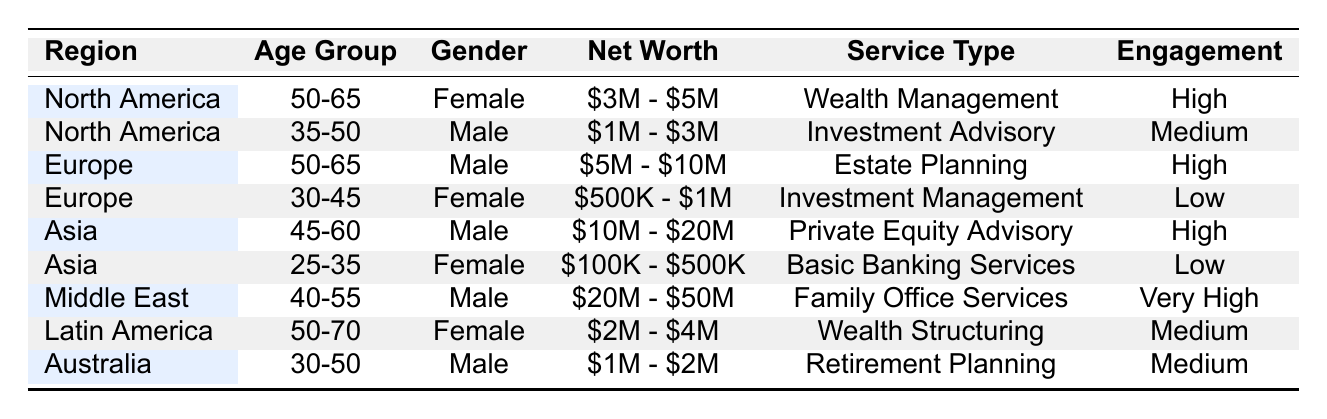What popular service type is associated with clients aged 50-65 in North America? In the North America section of the table, the entry with an age group of 50-65 shows the service type "Wealth Management."
Answer: Wealth Management Which region has the highest engagement level for male clients? The Middle East has a male client in the age group 40-55 with an engagement level of "Very High."
Answer: Middle East What is the net worth range of the female clients in Asia? The female clients in Asia are in the age group 25-35, with a net worth range of "$100K - $500K."
Answer: $100K - $500K Are there any clients aged 30-45 in Europe? Yes, there is a female client aged 30-45 in Europe with a net worth of "$500K - $1M."
Answer: Yes How does the engagement level of clients in Latin America compare to those in Europe? In Latin America, the engagement level for clients aged 50-70 is "Medium." In Europe, the engagement level for the 50-65 male client is "High," while the 30-45 female client's engagement is "Low." Thus, engagement levels vary with one being medium and the other high or low.
Answer: Varies: High and Medium What percentage of the clients in this table are from the Asia region? There are 8 total entries in the table, and 2 are from Asia. Therefore, the percentage of clients from Asia is (2/8)*100 = 25%.
Answer: 25% Which net worth category has the greatest representation among female clients? The table has two female clients with net worth categories: one with "$3M - $5M" in North America and another with "$2M - $4M" in Latin America. The representation includes a range of "2M - 5M" dollars.
Answer: $2M - $5M If we wanted to find the average net worth of males in the table, what would that require? To find the average net worth of males, we would need to convert the ranges to numerical values, sum them up, and then divide by the number of male clients listed. The listed male clients have ranges of "$5M - $10M," "$10M - $20M," and "$20M - $50M." Calculating that involves more detailed estimates of these ranges.
Answer: Requires calculations Is the engagement level for clients in the 25-35 age group across all regions generally low? Yes, both females in Asia and Europe in the respective age group have "Low" engagement levels. This suggests that, in the cases presented, it is consistent.
Answer: Yes How many distinct net worth categories are represented in the table? The distinct net worth categories represented are "$3M - $5M," "$1M - $3M," "$5M - $10M," "$500K - $1M," "$10M - $20M," "$100K - $500K," "$20M - $50M," and "$2M - $4M." This totals 8 distinct categories.
Answer: 8 